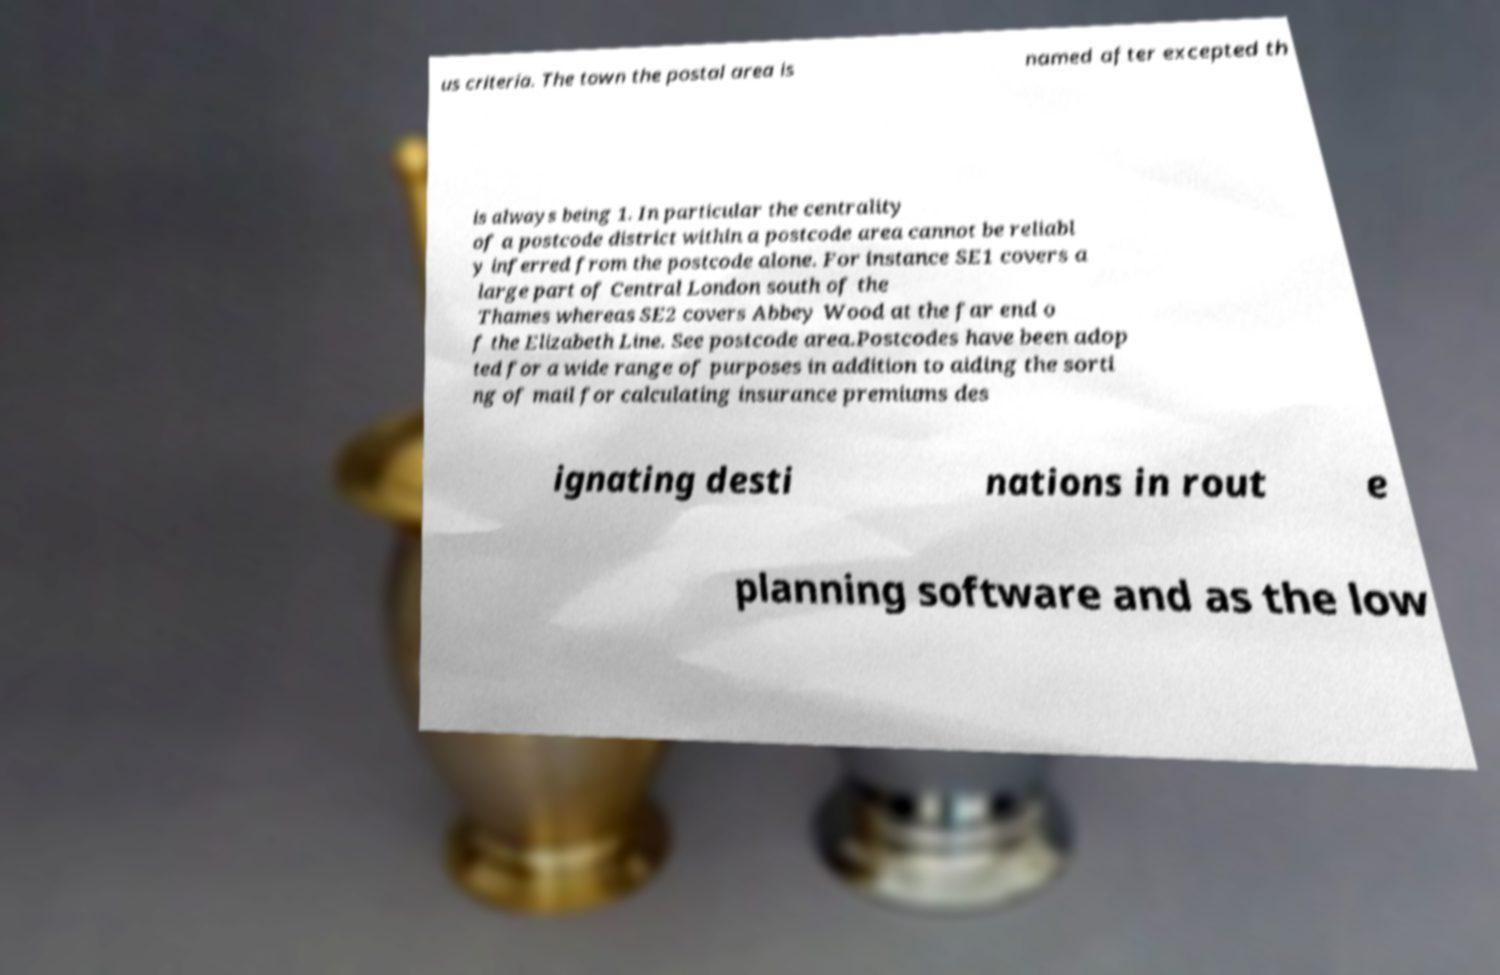Can you accurately transcribe the text from the provided image for me? us criteria. The town the postal area is named after excepted th is always being 1. In particular the centrality of a postcode district within a postcode area cannot be reliabl y inferred from the postcode alone. For instance SE1 covers a large part of Central London south of the Thames whereas SE2 covers Abbey Wood at the far end o f the Elizabeth Line. See postcode area.Postcodes have been adop ted for a wide range of purposes in addition to aiding the sorti ng of mail for calculating insurance premiums des ignating desti nations in rout e planning software and as the low 